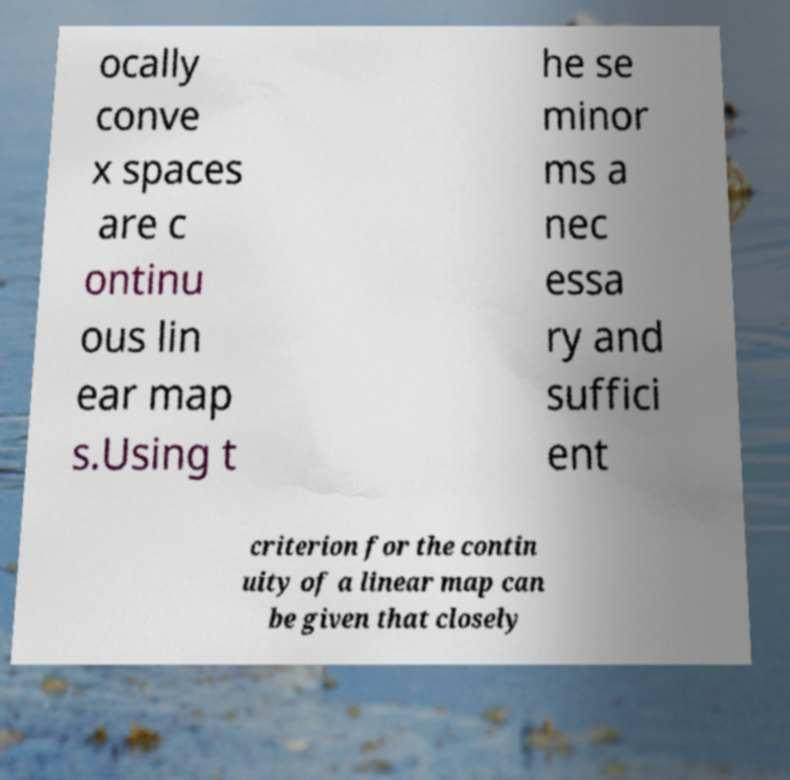I need the written content from this picture converted into text. Can you do that? ocally conve x spaces are c ontinu ous lin ear map s.Using t he se minor ms a nec essa ry and suffici ent criterion for the contin uity of a linear map can be given that closely 